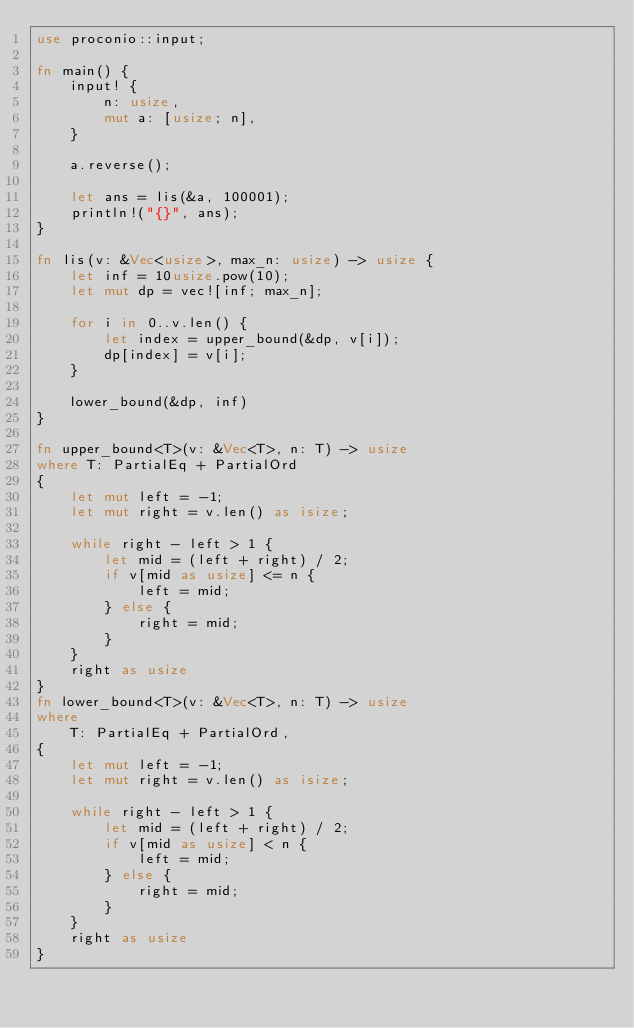<code> <loc_0><loc_0><loc_500><loc_500><_Rust_>use proconio::input;

fn main() {
    input! {
        n: usize,
        mut a: [usize; n],
    }

    a.reverse();

    let ans = lis(&a, 100001);
    println!("{}", ans);
}

fn lis(v: &Vec<usize>, max_n: usize) -> usize {
    let inf = 10usize.pow(10);
    let mut dp = vec![inf; max_n];

    for i in 0..v.len() {
        let index = upper_bound(&dp, v[i]);
        dp[index] = v[i];
    }

    lower_bound(&dp, inf)
}

fn upper_bound<T>(v: &Vec<T>, n: T) -> usize 
where T: PartialEq + PartialOrd
{
    let mut left = -1;
    let mut right = v.len() as isize;
    
    while right - left > 1 {
        let mid = (left + right) / 2;
        if v[mid as usize] <= n {
            left = mid;
        } else {
            right = mid;
        }
    } 
    right as usize
}
fn lower_bound<T>(v: &Vec<T>, n: T) -> usize
where
    T: PartialEq + PartialOrd,
{
    let mut left = -1;
    let mut right = v.len() as isize;

    while right - left > 1 {
        let mid = (left + right) / 2;
        if v[mid as usize] < n {
            left = mid;
        } else {
            right = mid;
        }
    }
    right as usize
}
</code> 